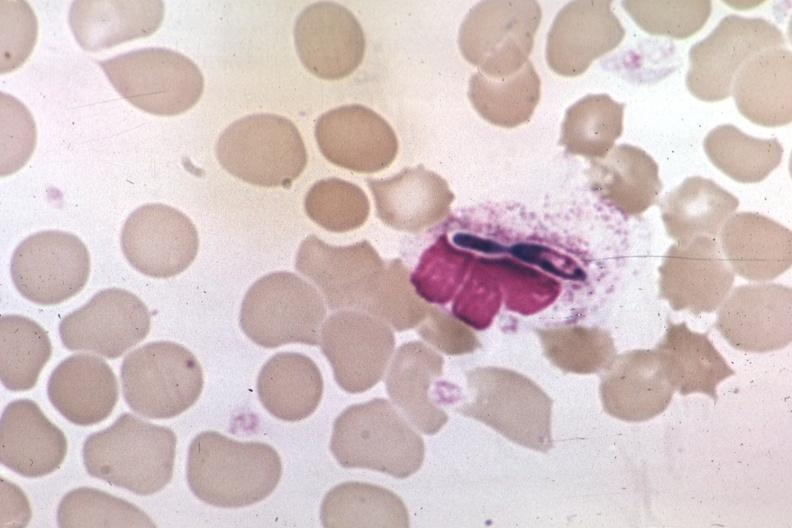what is present?
Answer the question using a single word or phrase. Candida in peripheral blood 